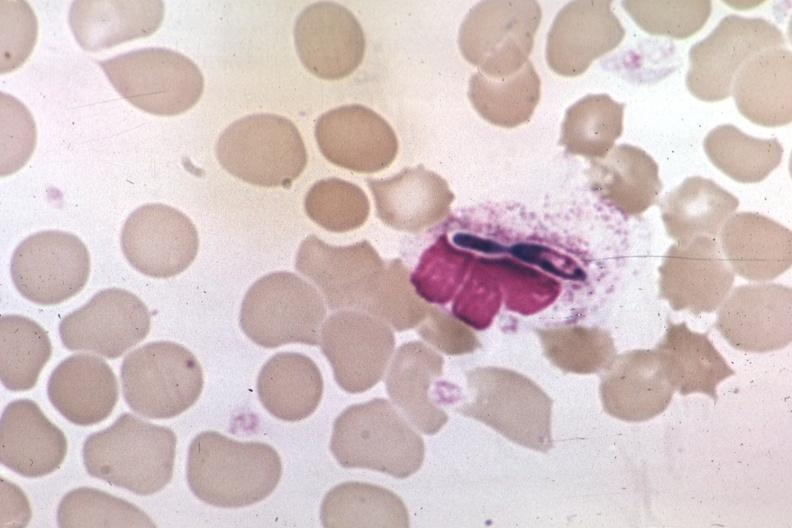what is present?
Answer the question using a single word or phrase. Candida in peripheral blood 